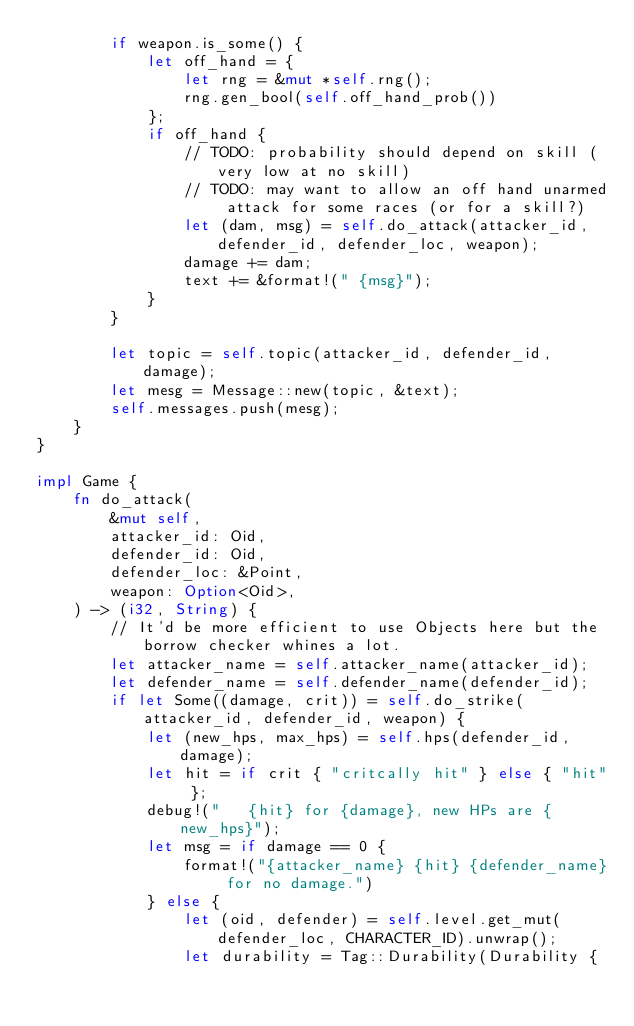<code> <loc_0><loc_0><loc_500><loc_500><_Rust_>        if weapon.is_some() {
            let off_hand = {
                let rng = &mut *self.rng();
                rng.gen_bool(self.off_hand_prob())
            };
            if off_hand {
                // TODO: probability should depend on skill (very low at no skill)
                // TODO: may want to allow an off hand unarmed attack for some races (or for a skill?)
                let (dam, msg) = self.do_attack(attacker_id, defender_id, defender_loc, weapon);
                damage += dam;
                text += &format!(" {msg}");
            }
        }

        let topic = self.topic(attacker_id, defender_id, damage);
        let mesg = Message::new(topic, &text);
        self.messages.push(mesg);
    }
}

impl Game {
    fn do_attack(
        &mut self,
        attacker_id: Oid,
        defender_id: Oid,
        defender_loc: &Point,
        weapon: Option<Oid>,
    ) -> (i32, String) {
        // It'd be more efficient to use Objects here but the borrow checker whines a lot.
        let attacker_name = self.attacker_name(attacker_id);
        let defender_name = self.defender_name(defender_id);
        if let Some((damage, crit)) = self.do_strike(attacker_id, defender_id, weapon) {
            let (new_hps, max_hps) = self.hps(defender_id, damage);
            let hit = if crit { "critcally hit" } else { "hit" };
            debug!("   {hit} for {damage}, new HPs are {new_hps}");
            let msg = if damage == 0 {
                format!("{attacker_name} {hit} {defender_name} for no damage.")
            } else {
                let (oid, defender) = self.level.get_mut(defender_loc, CHARACTER_ID).unwrap();
                let durability = Tag::Durability(Durability {</code> 